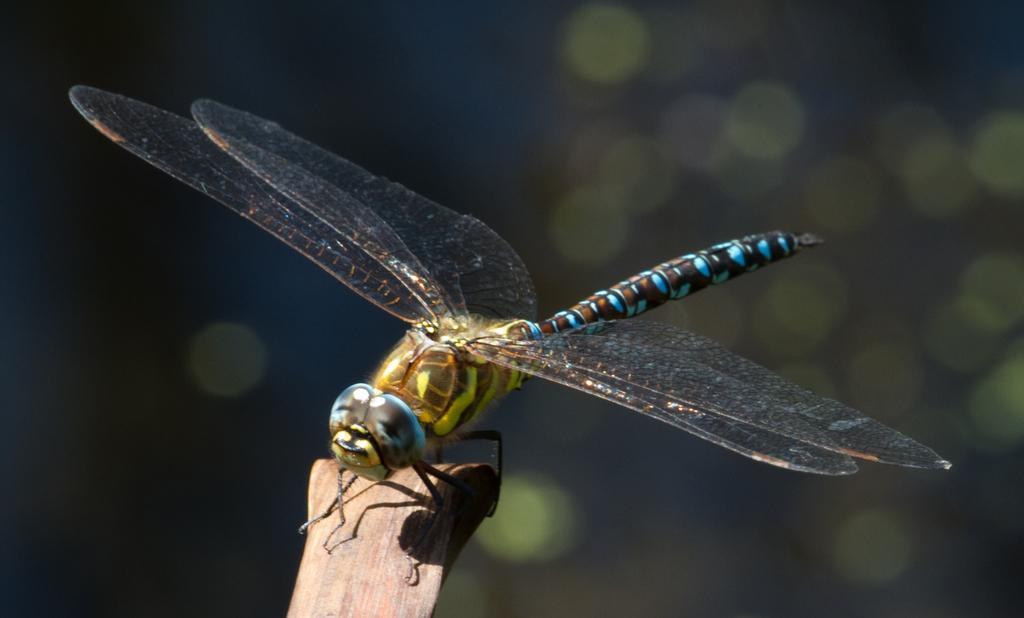How would you summarize this image in a sentence or two? In this picture we can see a dragonfly. 